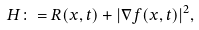Convert formula to latex. <formula><loc_0><loc_0><loc_500><loc_500>H \colon = R ( x , t ) + | \nabla f ( x , t ) | ^ { 2 } ,</formula> 